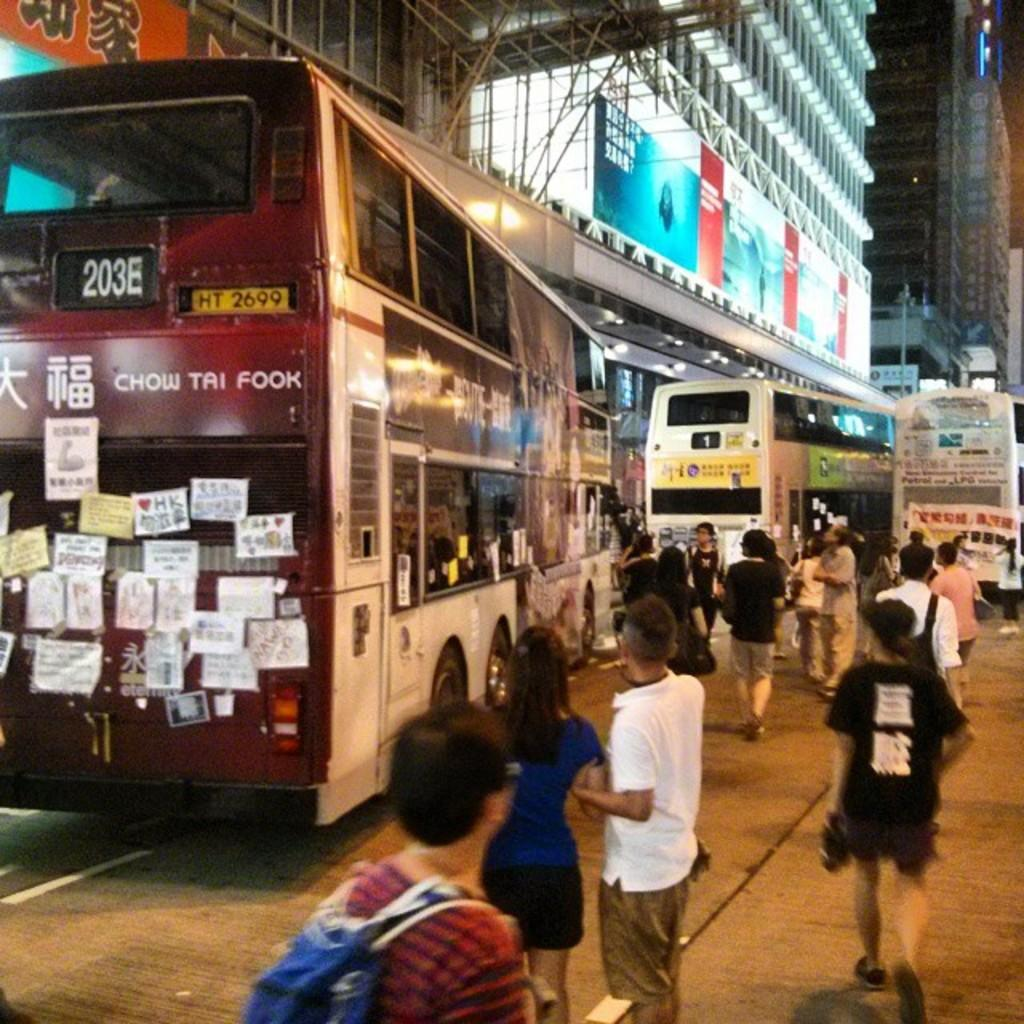<image>
Share a concise interpretation of the image provided. A red and white bus reads "CHOW TAI FOOK" on the back. 